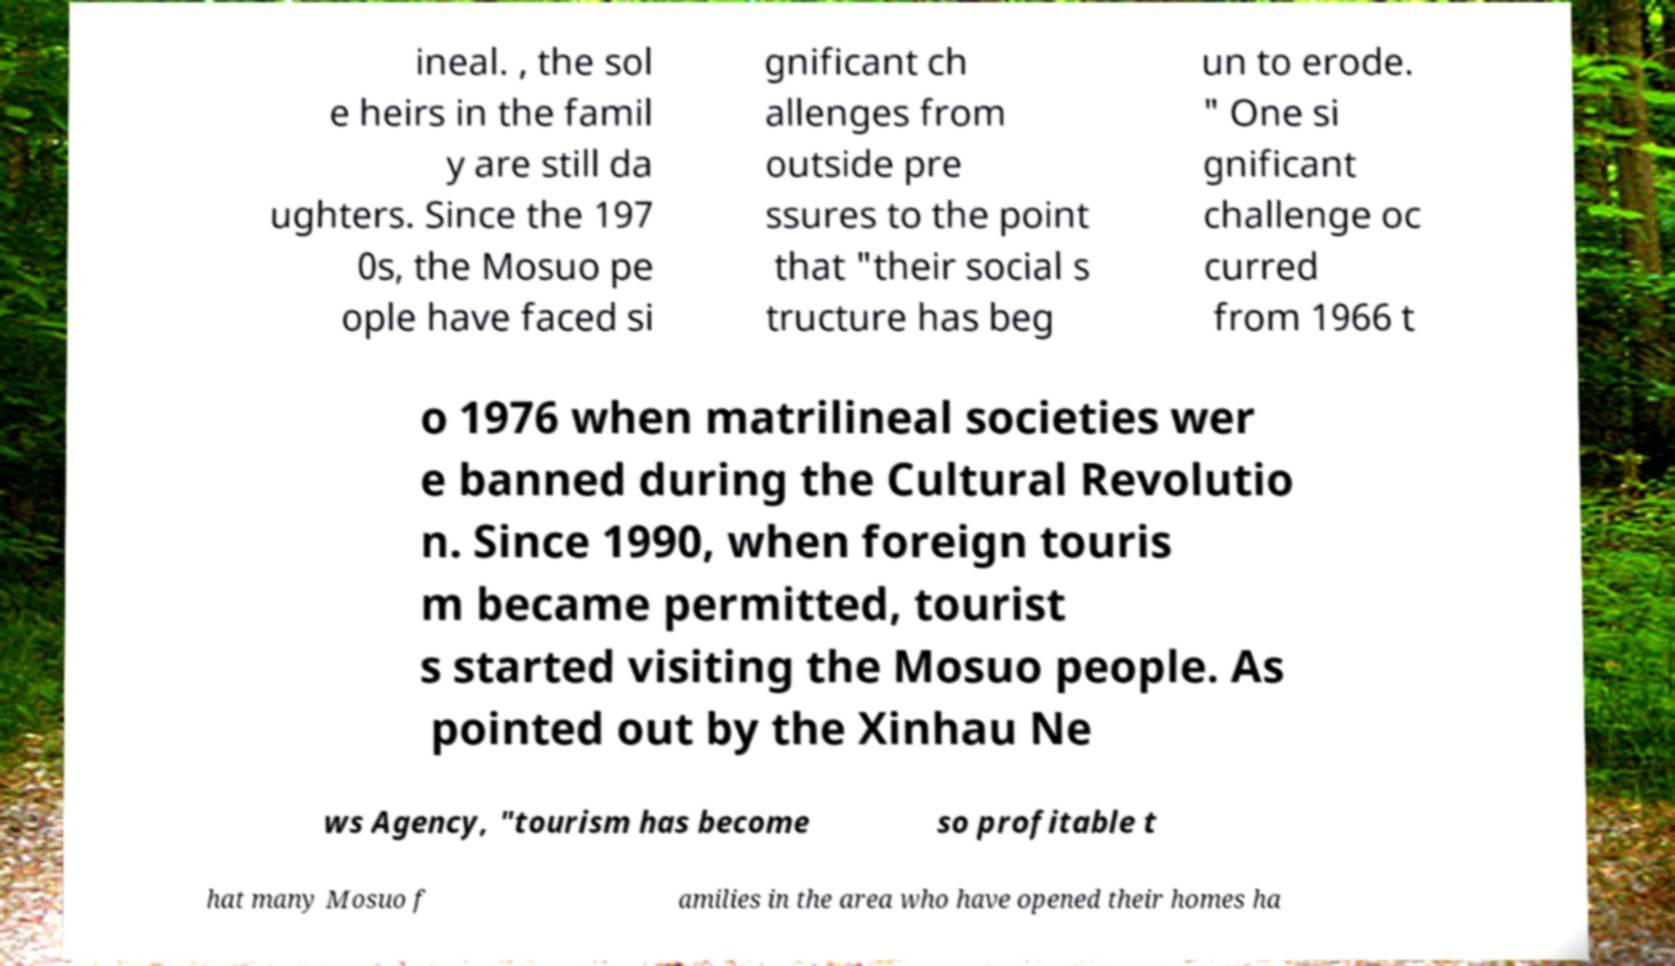Could you assist in decoding the text presented in this image and type it out clearly? ineal. , the sol e heirs in the famil y are still da ughters. Since the 197 0s, the Mosuo pe ople have faced si gnificant ch allenges from outside pre ssures to the point that "their social s tructure has beg un to erode. " One si gnificant challenge oc curred from 1966 t o 1976 when matrilineal societies wer e banned during the Cultural Revolutio n. Since 1990, when foreign touris m became permitted, tourist s started visiting the Mosuo people. As pointed out by the Xinhau Ne ws Agency, "tourism has become so profitable t hat many Mosuo f amilies in the area who have opened their homes ha 